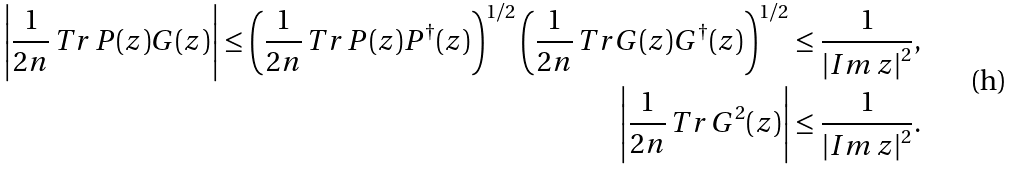Convert formula to latex. <formula><loc_0><loc_0><loc_500><loc_500>\left | \frac { 1 } { 2 n } \, T r \, P ( z ) G ( z ) \right | \leq \left ( \frac { 1 } { 2 n } \, T r \, P ( z ) P ^ { \dagger } ( z ) \right ) ^ { 1 / 2 } \left ( \frac { 1 } { 2 n } \, T r G ( z ) G ^ { \dagger } ( z ) \right ) ^ { 1 / 2 } \leq \frac { 1 } { \left | I m \, z \right | ^ { 2 } } , \\ \left | \frac { 1 } { 2 n } \, T r \, G ^ { 2 } ( z ) \right | \leq \frac { 1 } { \left | I m \, z \right | ^ { 2 } } .</formula> 